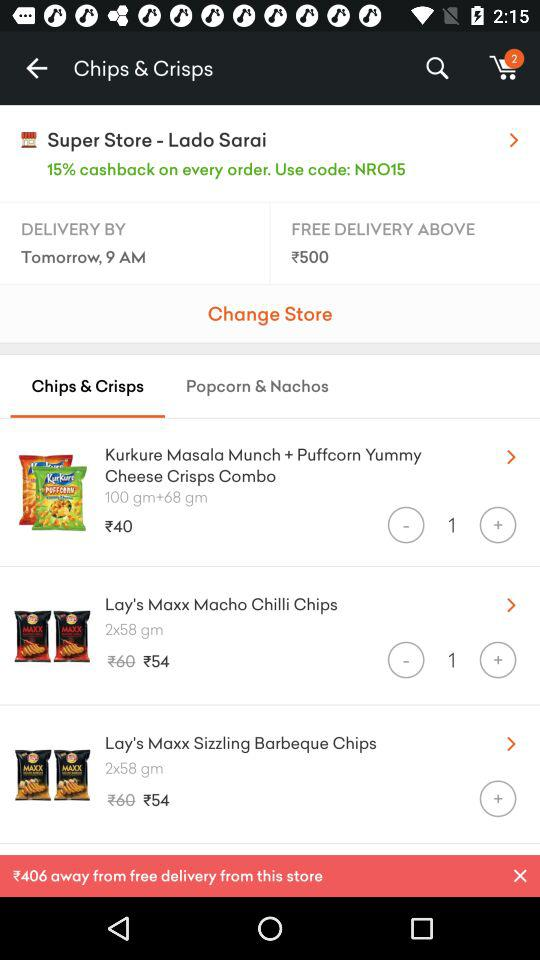What is the % of cashback on every order? The percentage of cashback is 15. 